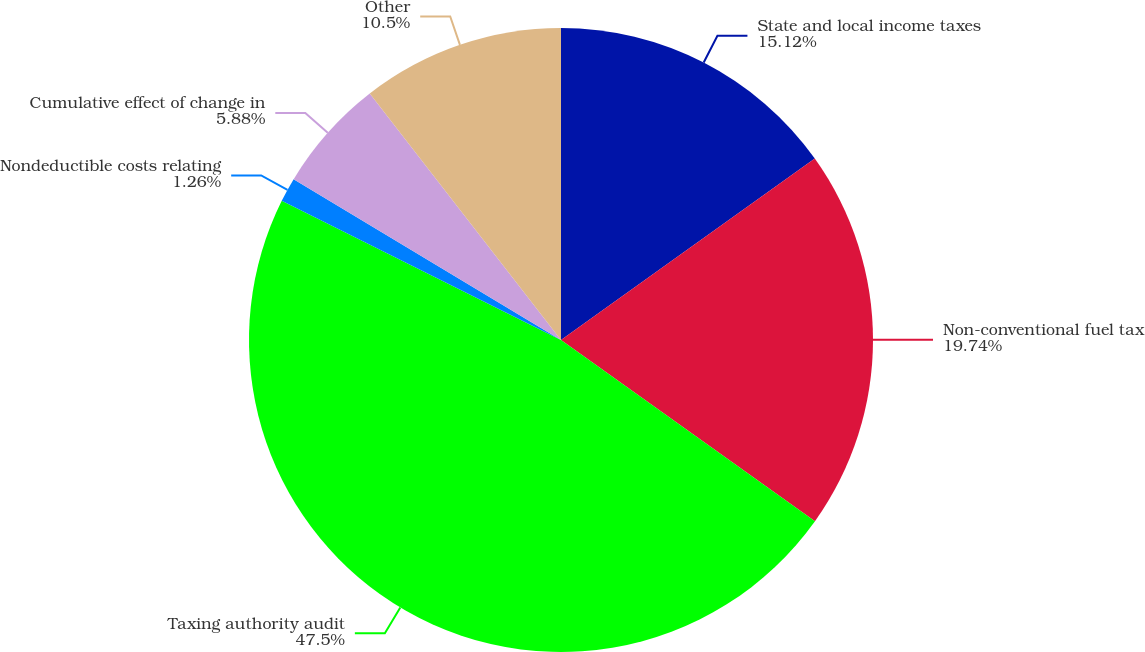Convert chart. <chart><loc_0><loc_0><loc_500><loc_500><pie_chart><fcel>State and local income taxes<fcel>Non-conventional fuel tax<fcel>Taxing authority audit<fcel>Nondeductible costs relating<fcel>Cumulative effect of change in<fcel>Other<nl><fcel>15.12%<fcel>19.74%<fcel>47.49%<fcel>1.26%<fcel>5.88%<fcel>10.5%<nl></chart> 